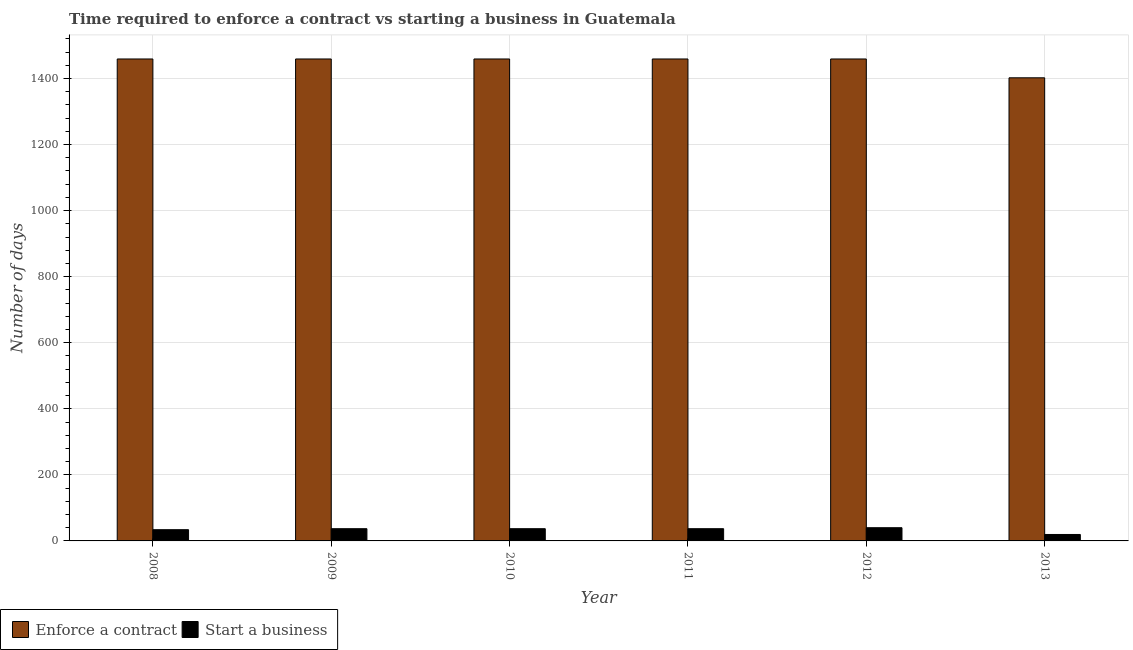How many bars are there on the 6th tick from the left?
Offer a terse response. 2. What is the label of the 4th group of bars from the left?
Offer a terse response. 2011. What is the number of days to start a business in 2008?
Offer a terse response. 34. Across all years, what is the maximum number of days to start a business?
Provide a succinct answer. 40. Across all years, what is the minimum number of days to enforece a contract?
Keep it short and to the point. 1402. In which year was the number of days to enforece a contract minimum?
Your answer should be compact. 2013. What is the total number of days to enforece a contract in the graph?
Ensure brevity in your answer.  8697. What is the difference between the number of days to enforece a contract in 2012 and that in 2013?
Offer a terse response. 57. What is the difference between the number of days to enforece a contract in 2009 and the number of days to start a business in 2013?
Keep it short and to the point. 57. What is the average number of days to enforece a contract per year?
Provide a short and direct response. 1449.5. In the year 2011, what is the difference between the number of days to enforece a contract and number of days to start a business?
Keep it short and to the point. 0. In how many years, is the number of days to start a business greater than 1440 days?
Give a very brief answer. 0. Is the number of days to enforece a contract in 2009 less than that in 2010?
Make the answer very short. No. What is the difference between the highest and the second highest number of days to enforece a contract?
Give a very brief answer. 0. In how many years, is the number of days to start a business greater than the average number of days to start a business taken over all years?
Provide a succinct answer. 4. Is the sum of the number of days to start a business in 2008 and 2009 greater than the maximum number of days to enforece a contract across all years?
Give a very brief answer. Yes. What does the 1st bar from the left in 2012 represents?
Ensure brevity in your answer.  Enforce a contract. What does the 1st bar from the right in 2009 represents?
Make the answer very short. Start a business. How many bars are there?
Your answer should be very brief. 12. How many years are there in the graph?
Make the answer very short. 6. Are the values on the major ticks of Y-axis written in scientific E-notation?
Give a very brief answer. No. Does the graph contain any zero values?
Give a very brief answer. No. Where does the legend appear in the graph?
Offer a terse response. Bottom left. What is the title of the graph?
Keep it short and to the point. Time required to enforce a contract vs starting a business in Guatemala. What is the label or title of the Y-axis?
Offer a very short reply. Number of days. What is the Number of days of Enforce a contract in 2008?
Offer a terse response. 1459. What is the Number of days of Enforce a contract in 2009?
Keep it short and to the point. 1459. What is the Number of days in Start a business in 2009?
Your response must be concise. 37. What is the Number of days of Enforce a contract in 2010?
Offer a very short reply. 1459. What is the Number of days of Start a business in 2010?
Make the answer very short. 37. What is the Number of days in Enforce a contract in 2011?
Provide a succinct answer. 1459. What is the Number of days in Enforce a contract in 2012?
Give a very brief answer. 1459. What is the Number of days in Start a business in 2012?
Keep it short and to the point. 40. What is the Number of days in Enforce a contract in 2013?
Make the answer very short. 1402. Across all years, what is the maximum Number of days in Enforce a contract?
Provide a succinct answer. 1459. Across all years, what is the minimum Number of days of Enforce a contract?
Ensure brevity in your answer.  1402. What is the total Number of days in Enforce a contract in the graph?
Provide a succinct answer. 8697. What is the total Number of days in Start a business in the graph?
Your answer should be very brief. 204.5. What is the difference between the Number of days of Start a business in 2008 and that in 2009?
Provide a succinct answer. -3. What is the difference between the Number of days of Enforce a contract in 2008 and that in 2011?
Make the answer very short. 0. What is the difference between the Number of days of Start a business in 2008 and that in 2011?
Keep it short and to the point. -3. What is the difference between the Number of days of Enforce a contract in 2008 and that in 2012?
Keep it short and to the point. 0. What is the difference between the Number of days of Start a business in 2008 and that in 2012?
Provide a succinct answer. -6. What is the difference between the Number of days in Enforce a contract in 2008 and that in 2013?
Provide a short and direct response. 57. What is the difference between the Number of days of Start a business in 2008 and that in 2013?
Your answer should be very brief. 14.5. What is the difference between the Number of days of Enforce a contract in 2009 and that in 2011?
Your answer should be very brief. 0. What is the difference between the Number of days of Start a business in 2009 and that in 2011?
Provide a short and direct response. 0. What is the difference between the Number of days of Start a business in 2009 and that in 2012?
Keep it short and to the point. -3. What is the difference between the Number of days of Enforce a contract in 2009 and that in 2013?
Your response must be concise. 57. What is the difference between the Number of days in Start a business in 2009 and that in 2013?
Keep it short and to the point. 17.5. What is the difference between the Number of days in Enforce a contract in 2010 and that in 2012?
Your answer should be compact. 0. What is the difference between the Number of days in Enforce a contract in 2010 and that in 2013?
Offer a very short reply. 57. What is the difference between the Number of days in Start a business in 2010 and that in 2013?
Make the answer very short. 17.5. What is the difference between the Number of days in Enforce a contract in 2011 and that in 2012?
Your response must be concise. 0. What is the difference between the Number of days of Enforce a contract in 2011 and that in 2013?
Your response must be concise. 57. What is the difference between the Number of days in Enforce a contract in 2008 and the Number of days in Start a business in 2009?
Your answer should be very brief. 1422. What is the difference between the Number of days in Enforce a contract in 2008 and the Number of days in Start a business in 2010?
Provide a short and direct response. 1422. What is the difference between the Number of days in Enforce a contract in 2008 and the Number of days in Start a business in 2011?
Your answer should be compact. 1422. What is the difference between the Number of days of Enforce a contract in 2008 and the Number of days of Start a business in 2012?
Offer a terse response. 1419. What is the difference between the Number of days of Enforce a contract in 2008 and the Number of days of Start a business in 2013?
Ensure brevity in your answer.  1439.5. What is the difference between the Number of days in Enforce a contract in 2009 and the Number of days in Start a business in 2010?
Ensure brevity in your answer.  1422. What is the difference between the Number of days in Enforce a contract in 2009 and the Number of days in Start a business in 2011?
Keep it short and to the point. 1422. What is the difference between the Number of days of Enforce a contract in 2009 and the Number of days of Start a business in 2012?
Your answer should be compact. 1419. What is the difference between the Number of days of Enforce a contract in 2009 and the Number of days of Start a business in 2013?
Ensure brevity in your answer.  1439.5. What is the difference between the Number of days in Enforce a contract in 2010 and the Number of days in Start a business in 2011?
Provide a succinct answer. 1422. What is the difference between the Number of days in Enforce a contract in 2010 and the Number of days in Start a business in 2012?
Your response must be concise. 1419. What is the difference between the Number of days of Enforce a contract in 2010 and the Number of days of Start a business in 2013?
Your answer should be compact. 1439.5. What is the difference between the Number of days of Enforce a contract in 2011 and the Number of days of Start a business in 2012?
Provide a succinct answer. 1419. What is the difference between the Number of days in Enforce a contract in 2011 and the Number of days in Start a business in 2013?
Keep it short and to the point. 1439.5. What is the difference between the Number of days in Enforce a contract in 2012 and the Number of days in Start a business in 2013?
Ensure brevity in your answer.  1439.5. What is the average Number of days of Enforce a contract per year?
Keep it short and to the point. 1449.5. What is the average Number of days of Start a business per year?
Keep it short and to the point. 34.08. In the year 2008, what is the difference between the Number of days in Enforce a contract and Number of days in Start a business?
Make the answer very short. 1425. In the year 2009, what is the difference between the Number of days of Enforce a contract and Number of days of Start a business?
Your answer should be very brief. 1422. In the year 2010, what is the difference between the Number of days in Enforce a contract and Number of days in Start a business?
Make the answer very short. 1422. In the year 2011, what is the difference between the Number of days of Enforce a contract and Number of days of Start a business?
Provide a succinct answer. 1422. In the year 2012, what is the difference between the Number of days in Enforce a contract and Number of days in Start a business?
Give a very brief answer. 1419. In the year 2013, what is the difference between the Number of days of Enforce a contract and Number of days of Start a business?
Keep it short and to the point. 1382.5. What is the ratio of the Number of days of Enforce a contract in 2008 to that in 2009?
Your answer should be compact. 1. What is the ratio of the Number of days in Start a business in 2008 to that in 2009?
Offer a very short reply. 0.92. What is the ratio of the Number of days in Start a business in 2008 to that in 2010?
Offer a terse response. 0.92. What is the ratio of the Number of days of Start a business in 2008 to that in 2011?
Offer a terse response. 0.92. What is the ratio of the Number of days in Start a business in 2008 to that in 2012?
Your answer should be compact. 0.85. What is the ratio of the Number of days of Enforce a contract in 2008 to that in 2013?
Your answer should be compact. 1.04. What is the ratio of the Number of days of Start a business in 2008 to that in 2013?
Offer a very short reply. 1.74. What is the ratio of the Number of days of Enforce a contract in 2009 to that in 2010?
Make the answer very short. 1. What is the ratio of the Number of days of Start a business in 2009 to that in 2010?
Ensure brevity in your answer.  1. What is the ratio of the Number of days of Start a business in 2009 to that in 2012?
Provide a succinct answer. 0.93. What is the ratio of the Number of days in Enforce a contract in 2009 to that in 2013?
Your response must be concise. 1.04. What is the ratio of the Number of days of Start a business in 2009 to that in 2013?
Your answer should be compact. 1.9. What is the ratio of the Number of days of Enforce a contract in 2010 to that in 2011?
Offer a very short reply. 1. What is the ratio of the Number of days in Start a business in 2010 to that in 2011?
Your answer should be very brief. 1. What is the ratio of the Number of days in Enforce a contract in 2010 to that in 2012?
Ensure brevity in your answer.  1. What is the ratio of the Number of days of Start a business in 2010 to that in 2012?
Your answer should be compact. 0.93. What is the ratio of the Number of days of Enforce a contract in 2010 to that in 2013?
Your response must be concise. 1.04. What is the ratio of the Number of days in Start a business in 2010 to that in 2013?
Your answer should be compact. 1.9. What is the ratio of the Number of days in Start a business in 2011 to that in 2012?
Provide a succinct answer. 0.93. What is the ratio of the Number of days in Enforce a contract in 2011 to that in 2013?
Ensure brevity in your answer.  1.04. What is the ratio of the Number of days of Start a business in 2011 to that in 2013?
Your answer should be compact. 1.9. What is the ratio of the Number of days in Enforce a contract in 2012 to that in 2013?
Provide a succinct answer. 1.04. What is the ratio of the Number of days in Start a business in 2012 to that in 2013?
Your answer should be very brief. 2.05. What is the difference between the highest and the second highest Number of days of Enforce a contract?
Make the answer very short. 0. What is the difference between the highest and the lowest Number of days in Enforce a contract?
Keep it short and to the point. 57. 